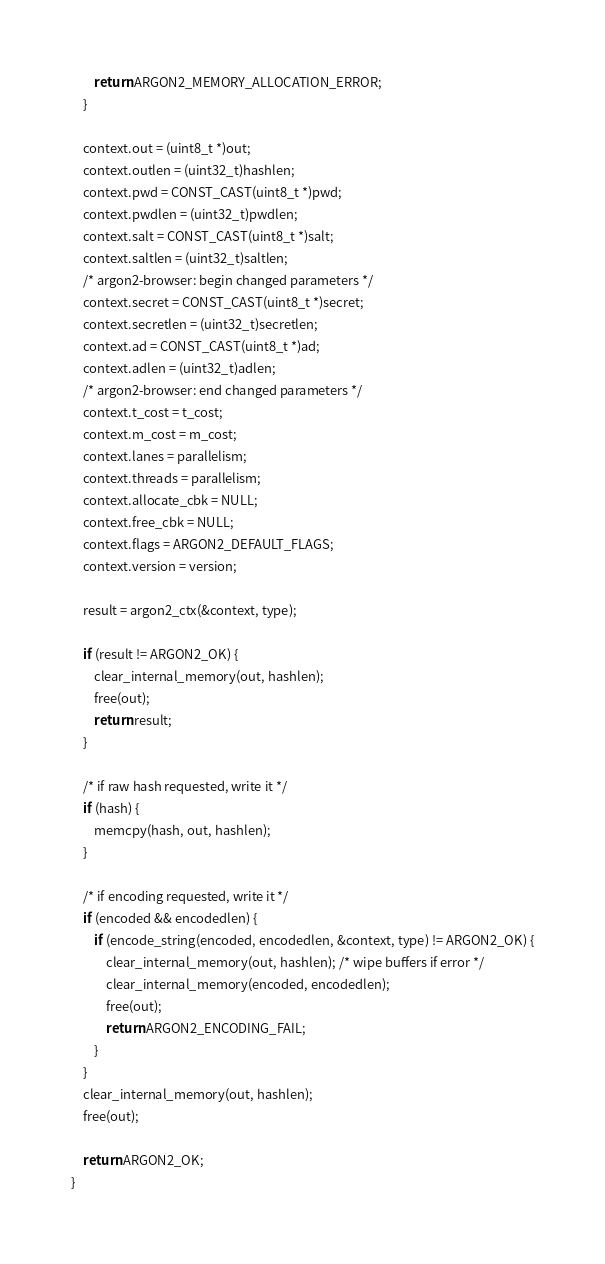Convert code to text. <code><loc_0><loc_0><loc_500><loc_500><_C_>        return ARGON2_MEMORY_ALLOCATION_ERROR;
    }

    context.out = (uint8_t *)out;
    context.outlen = (uint32_t)hashlen;
    context.pwd = CONST_CAST(uint8_t *)pwd;
    context.pwdlen = (uint32_t)pwdlen;
    context.salt = CONST_CAST(uint8_t *)salt;
    context.saltlen = (uint32_t)saltlen;
    /* argon2-browser: begin changed parameters */
    context.secret = CONST_CAST(uint8_t *)secret;
    context.secretlen = (uint32_t)secretlen;
    context.ad = CONST_CAST(uint8_t *)ad;
    context.adlen = (uint32_t)adlen;
    /* argon2-browser: end changed parameters */
    context.t_cost = t_cost;
    context.m_cost = m_cost;
    context.lanes = parallelism;
    context.threads = parallelism;
    context.allocate_cbk = NULL;
    context.free_cbk = NULL;
    context.flags = ARGON2_DEFAULT_FLAGS;
    context.version = version;

    result = argon2_ctx(&context, type);

    if (result != ARGON2_OK) {
        clear_internal_memory(out, hashlen);
        free(out);
        return result;
    }

    /* if raw hash requested, write it */
    if (hash) {
        memcpy(hash, out, hashlen);
    }

    /* if encoding requested, write it */
    if (encoded && encodedlen) {
        if (encode_string(encoded, encodedlen, &context, type) != ARGON2_OK) {
            clear_internal_memory(out, hashlen); /* wipe buffers if error */
            clear_internal_memory(encoded, encodedlen);
            free(out);
            return ARGON2_ENCODING_FAIL;
        }
    }
    clear_internal_memory(out, hashlen);
    free(out);

    return ARGON2_OK;
}
</code> 